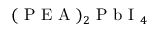Convert formula to latex. <formula><loc_0><loc_0><loc_500><loc_500>( P E A ) _ { 2 } P b I _ { 4 }</formula> 